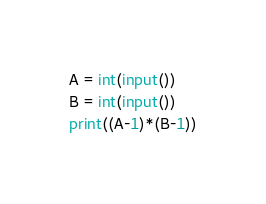Convert code to text. <code><loc_0><loc_0><loc_500><loc_500><_Python_>A = int(input())
B = int(input())
print((A-1)*(B-1))</code> 